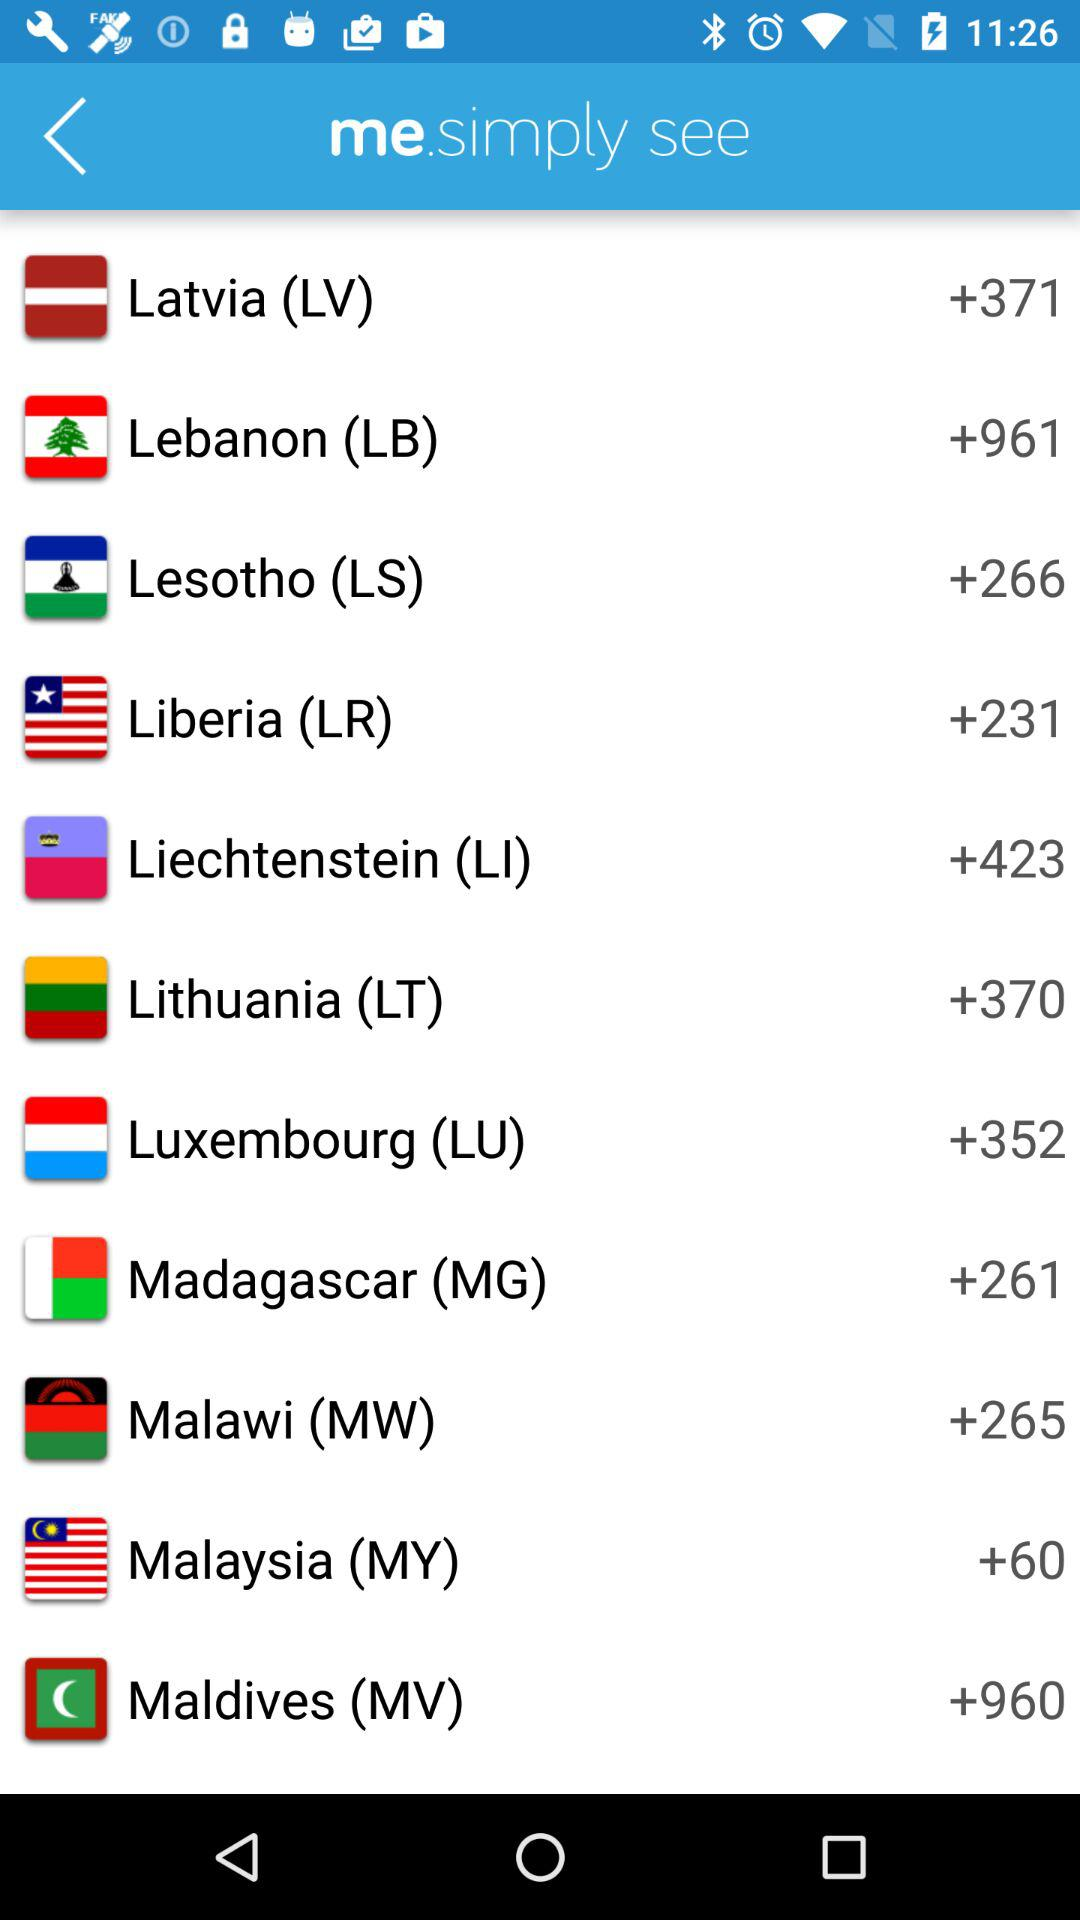Which country has the country code of +370? The country that has the country code of +370 is Lithuania (LT). 